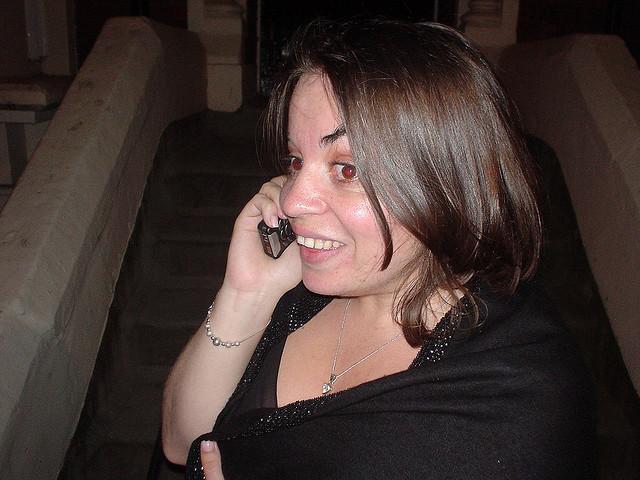How many people are in the photo?
Give a very brief answer. 1. 